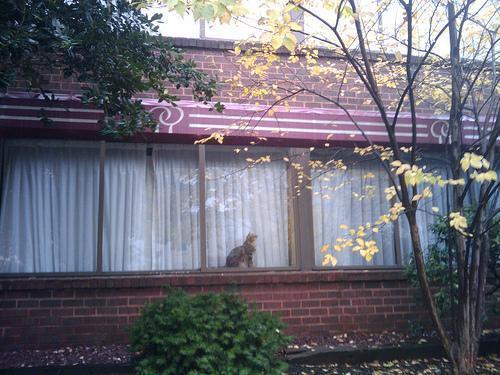How many cats are in the picture?
Give a very brief answer. 1. 